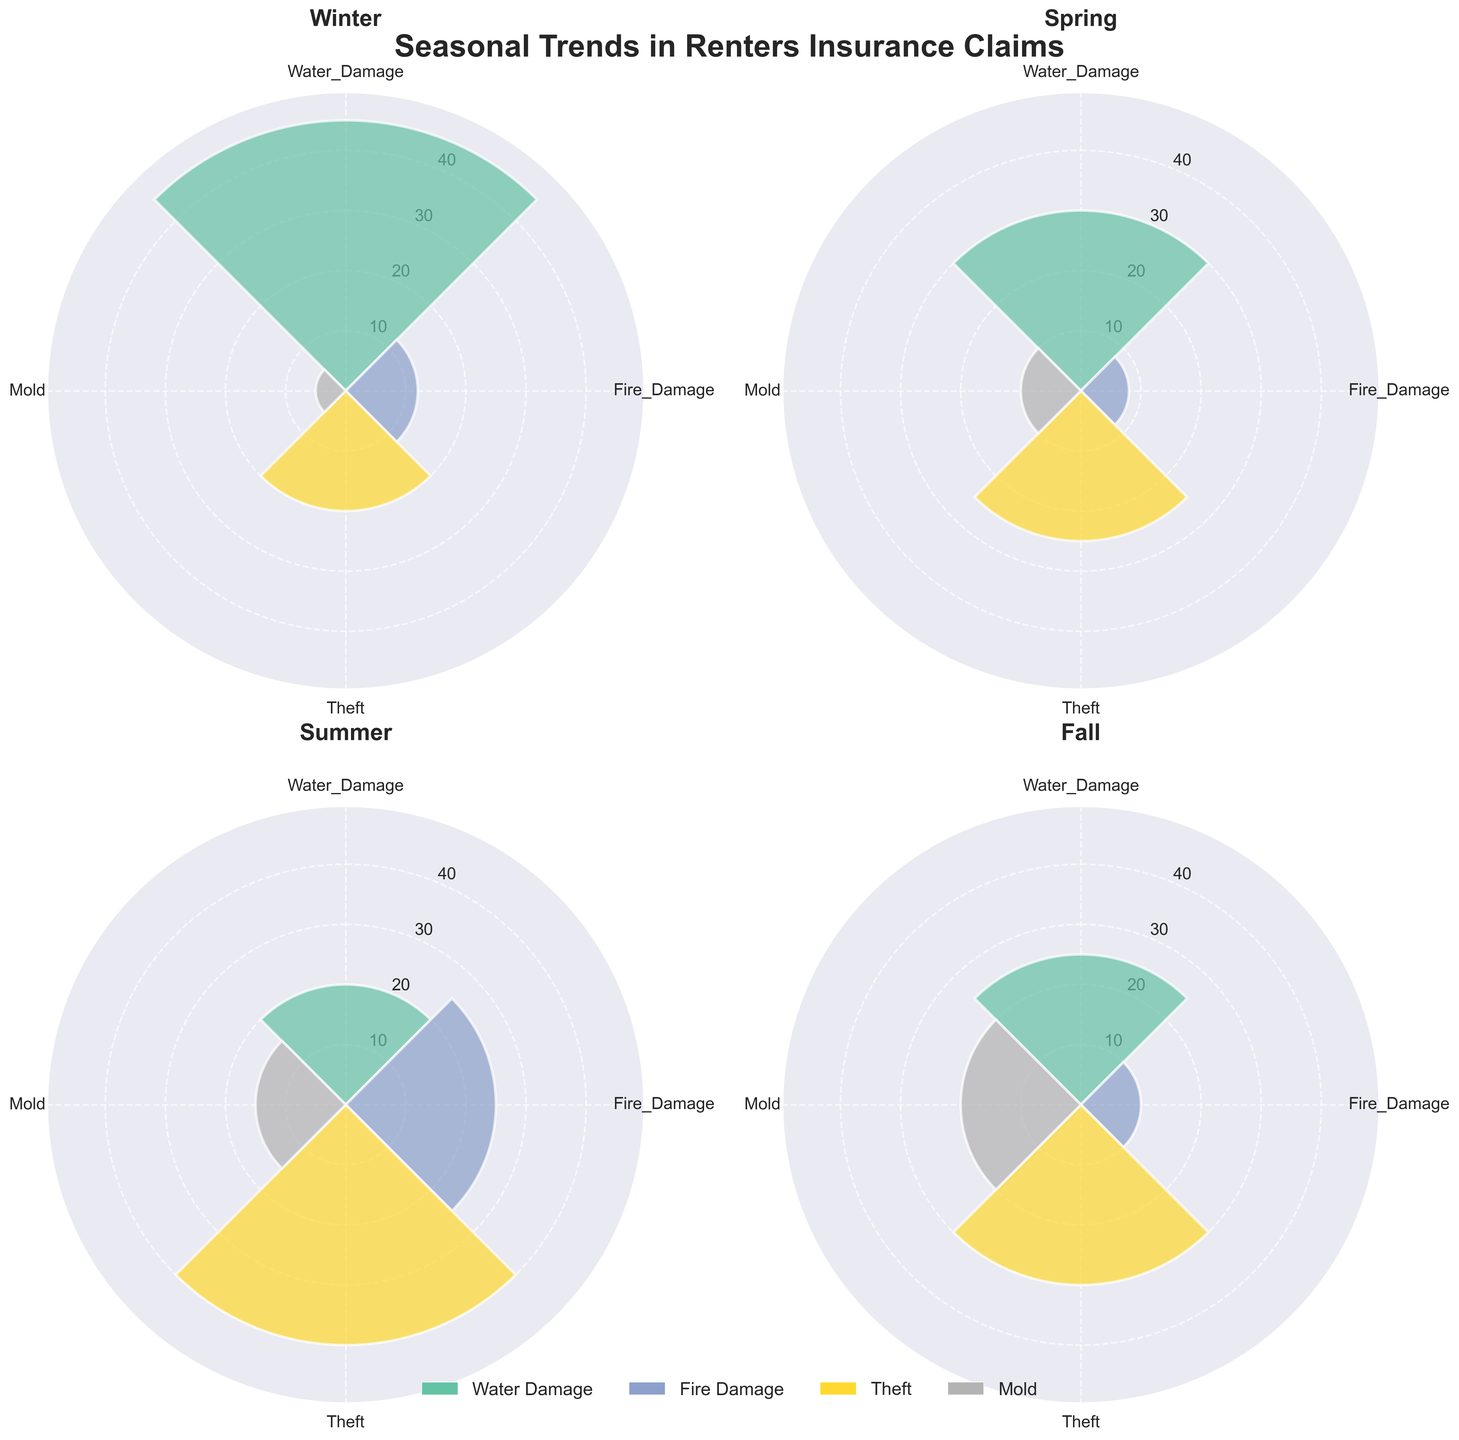Which season has the highest number of Fire_Damage claims? By looking at each subplot, identify the season with the largest bar segment for Fire_Damage. Observing this, Fire_Damage claims are highest in the Summer subplot.
Answer: Summer What is the total number of claims for Water_Damage across all seasons? Add the claims for Water_Damage for each season: Winter (45), Spring (30), Summer (20), Fall (25). The total is 45 + 30 + 20 + 25.
Answer: 120 How does the number of Theft claims in Winter compare to Fall? Compare the height of the bars representing Theft claims in Winter (20) and Fall (30). Since 20 < 30, there are fewer Theft claims in Winter compared to Fall.
Answer: Fewer in Winter Which type of damage has the highest number of claims in Spring? Look at the Spring subplot and identify the tallest bar which corresponds to the type of damage with the highest claims. The Theft segment is the tallest.
Answer: Theft In which season are Mold claims the lowest? Examine the bar segments for Mold across all seasons and identify the shortest bar. The shortest Mold bar is in the Winter subplot (5 claims).
Answer: Winter What is the average number of total claims per season? First, calculate the total number of claims for each season: Winter (45+12+20+5 = 82), Spring (30+8+25+10 = 73), Summer (20+25+40+15 = 100), Fall (25+10+30+20 = 85). Then find the average: (82 + 73 + 100 + 85) / 4.
Answer: 85 Which season has the least number of Thefts? Compare the Theft segments in each subplot. The shortest Theft bar is in Winter with 20 claims.
Answer: Winter What is the most frequent type of damage in Summer? Identify the tallest bar segment in the Summer subplot, which represents the most frequent type of damage. The Theft segment is the tallest.
Answer: Theft How many more claims were there for Water_Damage in Winter compared to Summer? Subtract the number of Summer Water_Damage claims (20) from the Winter Water_Damage claims (45): 45 - 20.
Answer: 25 Is the number of Fire_Damage claims higher in Winter or Spring? Compare the bar heights for Fire_Damage in Winter (12) and Spring (8). The Winter subplot shows higher claims.
Answer: Winter 